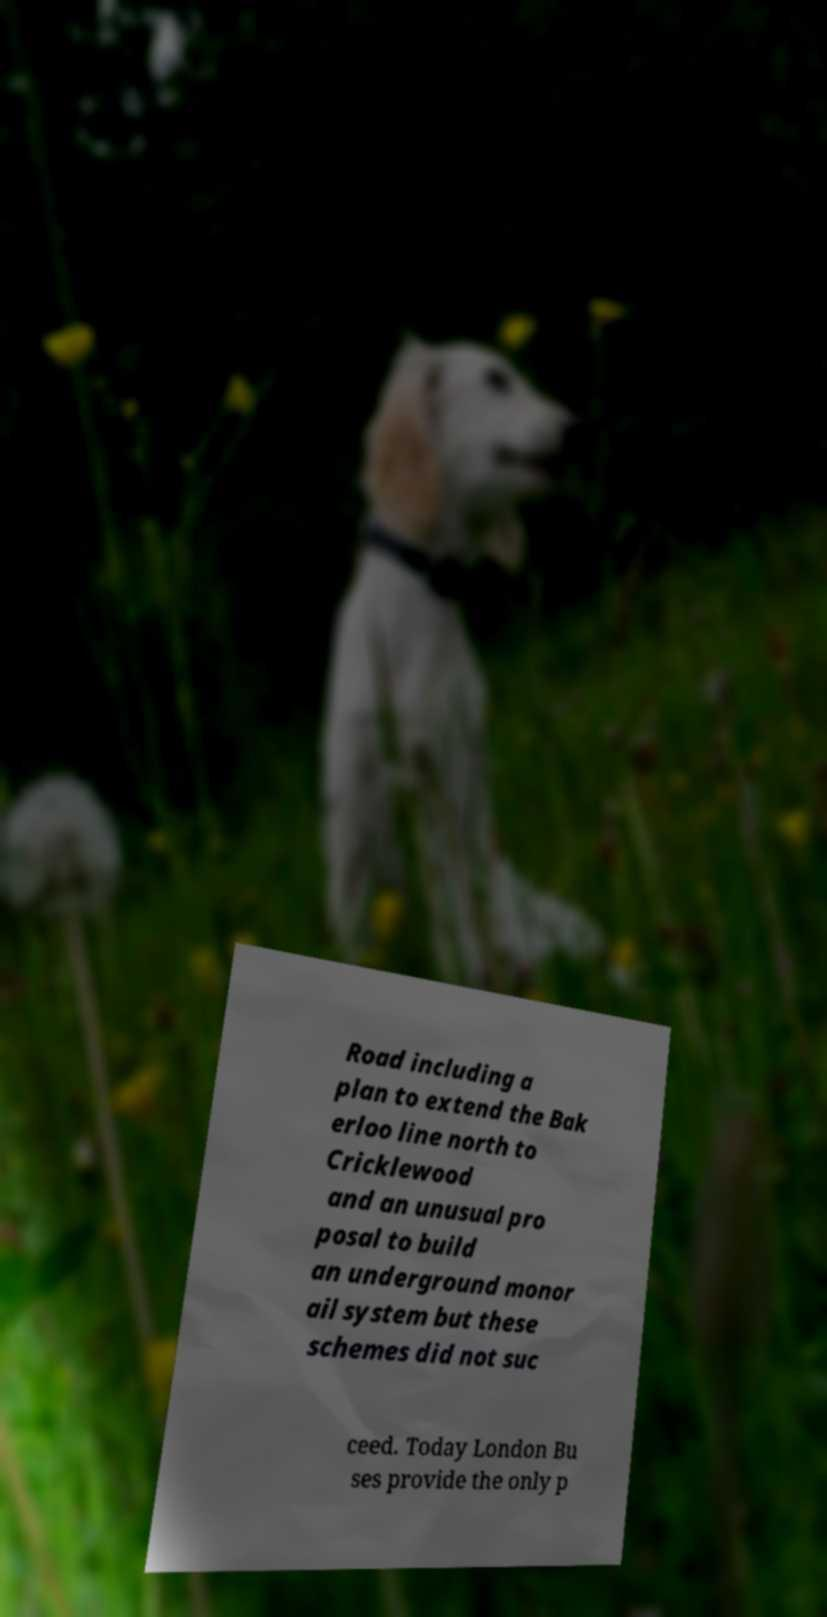Please read and relay the text visible in this image. What does it say? Road including a plan to extend the Bak erloo line north to Cricklewood and an unusual pro posal to build an underground monor ail system but these schemes did not suc ceed. Today London Bu ses provide the only p 